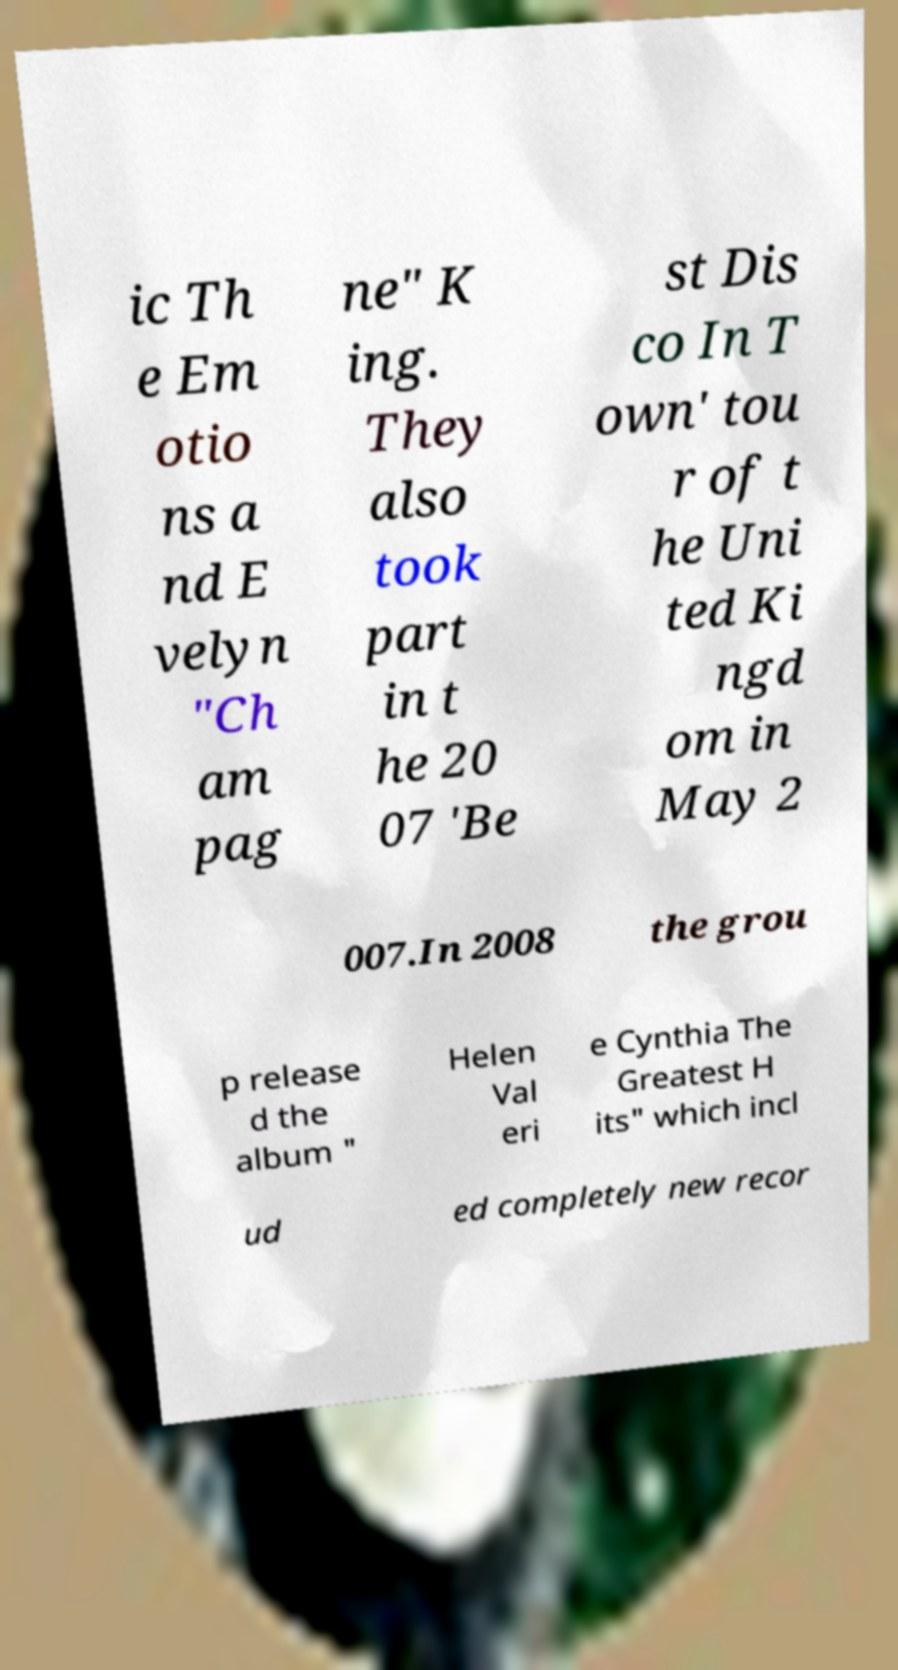Could you assist in decoding the text presented in this image and type it out clearly? ic Th e Em otio ns a nd E velyn "Ch am pag ne" K ing. They also took part in t he 20 07 'Be st Dis co In T own' tou r of t he Uni ted Ki ngd om in May 2 007.In 2008 the grou p release d the album " Helen Val eri e Cynthia The Greatest H its" which incl ud ed completely new recor 